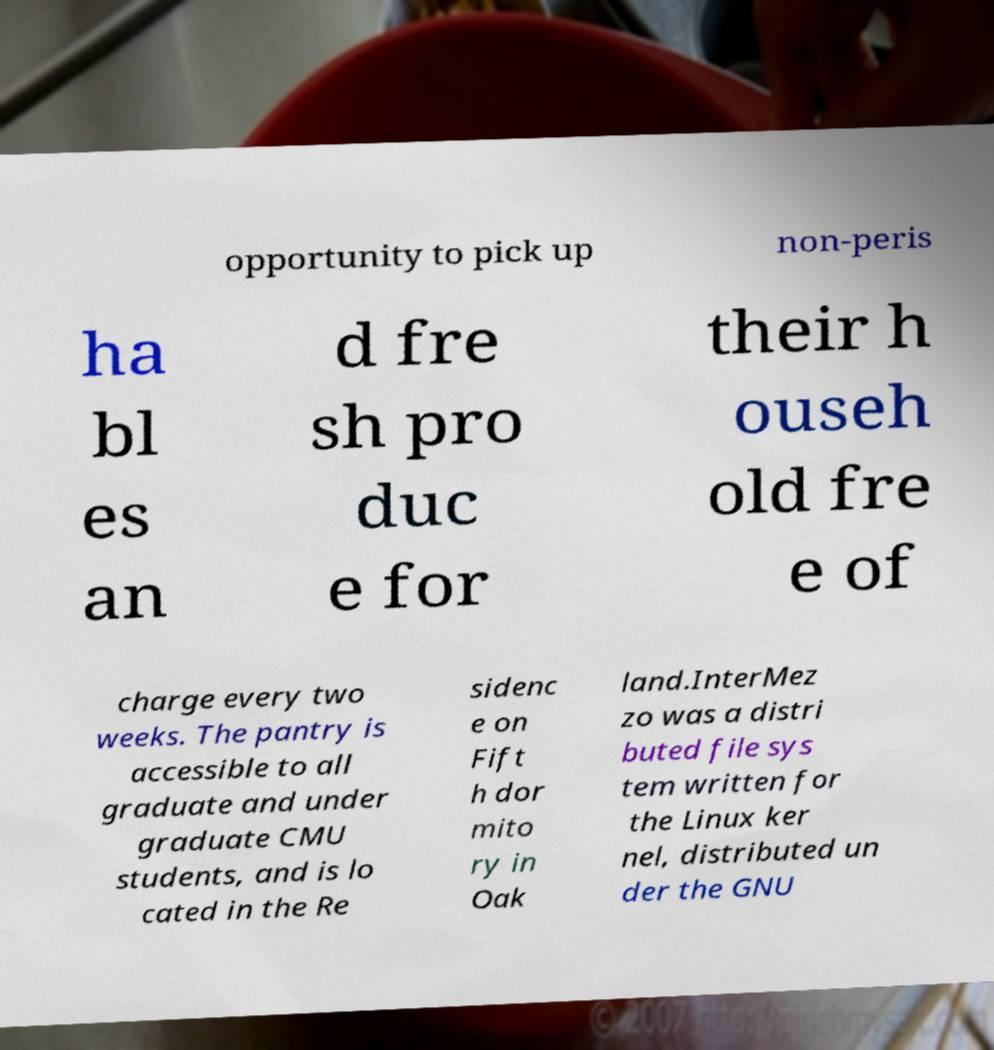Please identify and transcribe the text found in this image. opportunity to pick up non-peris ha bl es an d fre sh pro duc e for their h ouseh old fre e of charge every two weeks. The pantry is accessible to all graduate and under graduate CMU students, and is lo cated in the Re sidenc e on Fift h dor mito ry in Oak land.InterMez zo was a distri buted file sys tem written for the Linux ker nel, distributed un der the GNU 